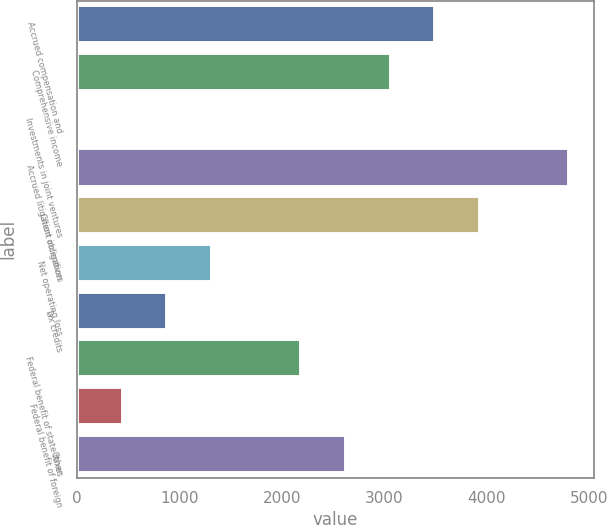<chart> <loc_0><loc_0><loc_500><loc_500><bar_chart><fcel>Accrued compensation and<fcel>Comprehensive income<fcel>Investments in joint ventures<fcel>Accrued litigation obligation<fcel>Client incentives<fcel>Net operating loss<fcel>Tax credits<fcel>Federal benefit of state taxes<fcel>Federal benefit of foreign<fcel>Other<nl><fcel>3497.4<fcel>3061.6<fcel>11<fcel>4804.8<fcel>3933.2<fcel>1318.4<fcel>882.6<fcel>2190<fcel>446.8<fcel>2625.8<nl></chart> 